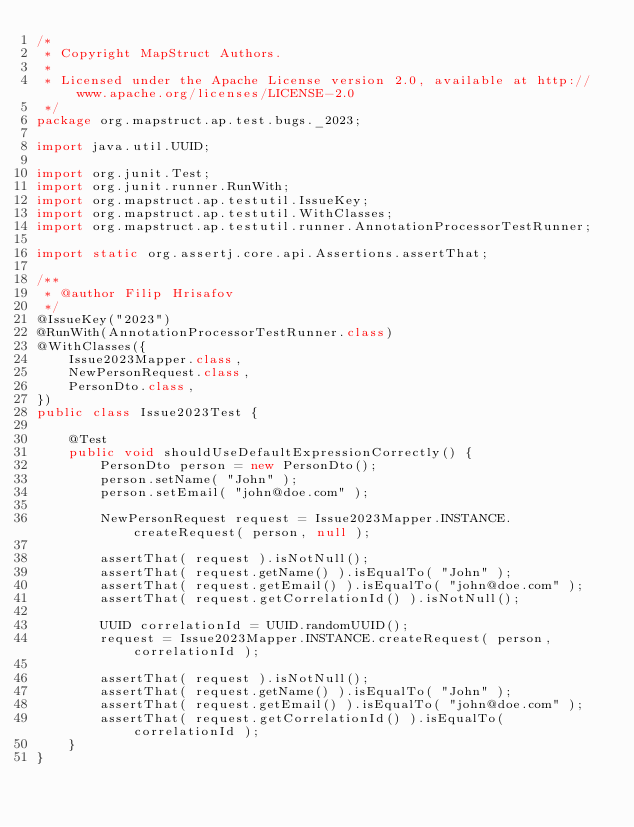Convert code to text. <code><loc_0><loc_0><loc_500><loc_500><_Java_>/*
 * Copyright MapStruct Authors.
 *
 * Licensed under the Apache License version 2.0, available at http://www.apache.org/licenses/LICENSE-2.0
 */
package org.mapstruct.ap.test.bugs._2023;

import java.util.UUID;

import org.junit.Test;
import org.junit.runner.RunWith;
import org.mapstruct.ap.testutil.IssueKey;
import org.mapstruct.ap.testutil.WithClasses;
import org.mapstruct.ap.testutil.runner.AnnotationProcessorTestRunner;

import static org.assertj.core.api.Assertions.assertThat;

/**
 * @author Filip Hrisafov
 */
@IssueKey("2023")
@RunWith(AnnotationProcessorTestRunner.class)
@WithClasses({
    Issue2023Mapper.class,
    NewPersonRequest.class,
    PersonDto.class,
})
public class Issue2023Test {

    @Test
    public void shouldUseDefaultExpressionCorrectly() {
        PersonDto person = new PersonDto();
        person.setName( "John" );
        person.setEmail( "john@doe.com" );

        NewPersonRequest request = Issue2023Mapper.INSTANCE.createRequest( person, null );

        assertThat( request ).isNotNull();
        assertThat( request.getName() ).isEqualTo( "John" );
        assertThat( request.getEmail() ).isEqualTo( "john@doe.com" );
        assertThat( request.getCorrelationId() ).isNotNull();

        UUID correlationId = UUID.randomUUID();
        request = Issue2023Mapper.INSTANCE.createRequest( person, correlationId );

        assertThat( request ).isNotNull();
        assertThat( request.getName() ).isEqualTo( "John" );
        assertThat( request.getEmail() ).isEqualTo( "john@doe.com" );
        assertThat( request.getCorrelationId() ).isEqualTo( correlationId );
    }
}
</code> 